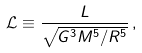<formula> <loc_0><loc_0><loc_500><loc_500>\mathcal { L } \equiv \frac { L } { \sqrt { G ^ { 3 } M ^ { 5 } / R ^ { 5 } } } \, ,</formula> 